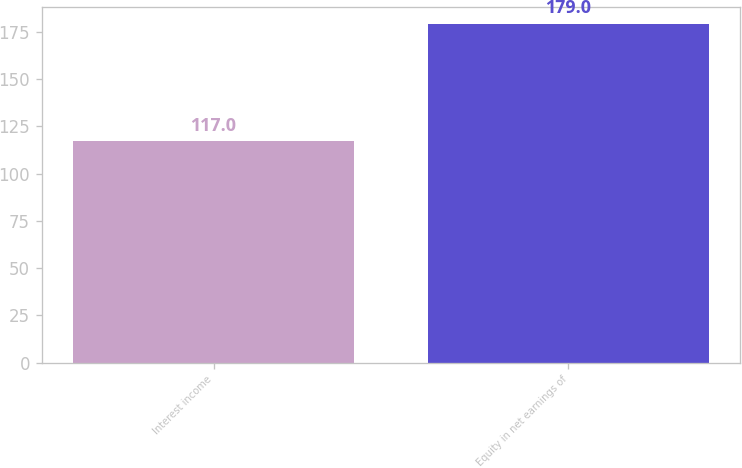Convert chart. <chart><loc_0><loc_0><loc_500><loc_500><bar_chart><fcel>Interest income<fcel>Equity in net earnings of<nl><fcel>117<fcel>179<nl></chart> 